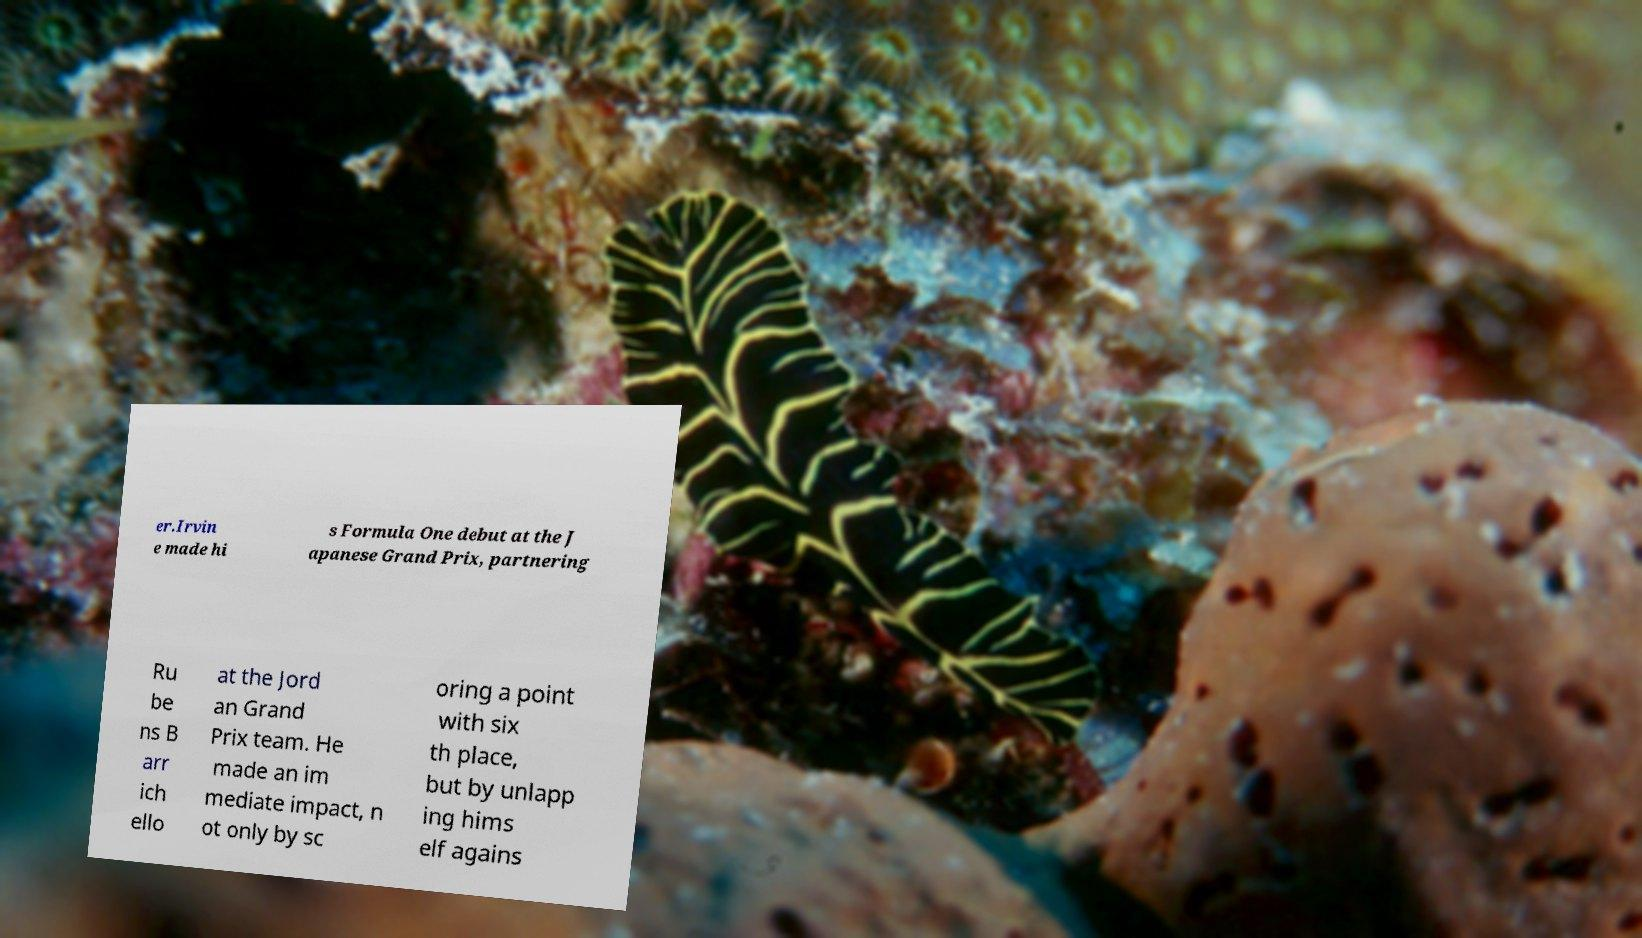There's text embedded in this image that I need extracted. Can you transcribe it verbatim? er.Irvin e made hi s Formula One debut at the J apanese Grand Prix, partnering Ru be ns B arr ich ello at the Jord an Grand Prix team. He made an im mediate impact, n ot only by sc oring a point with six th place, but by unlapp ing hims elf agains 